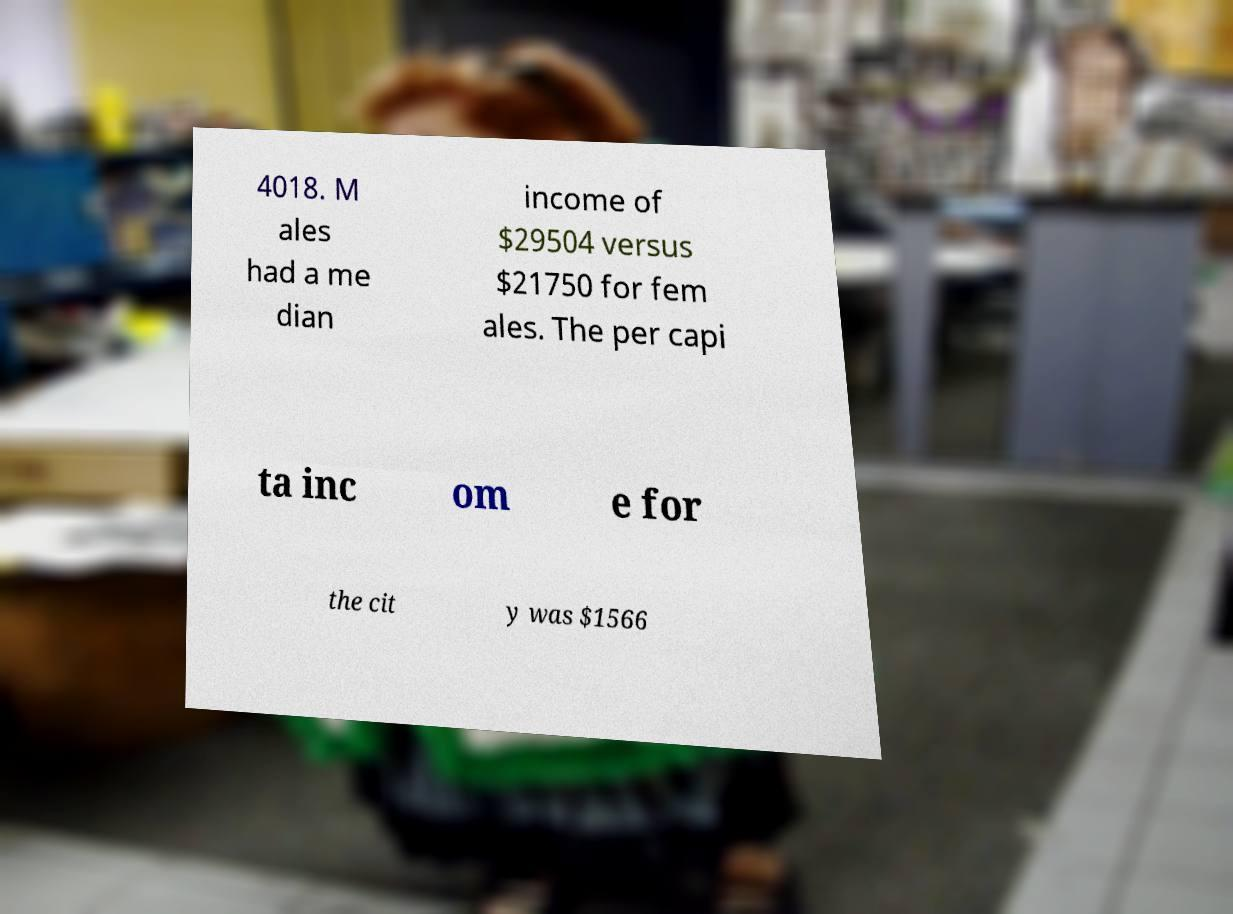There's text embedded in this image that I need extracted. Can you transcribe it verbatim? 4018. M ales had a me dian income of $29504 versus $21750 for fem ales. The per capi ta inc om e for the cit y was $1566 